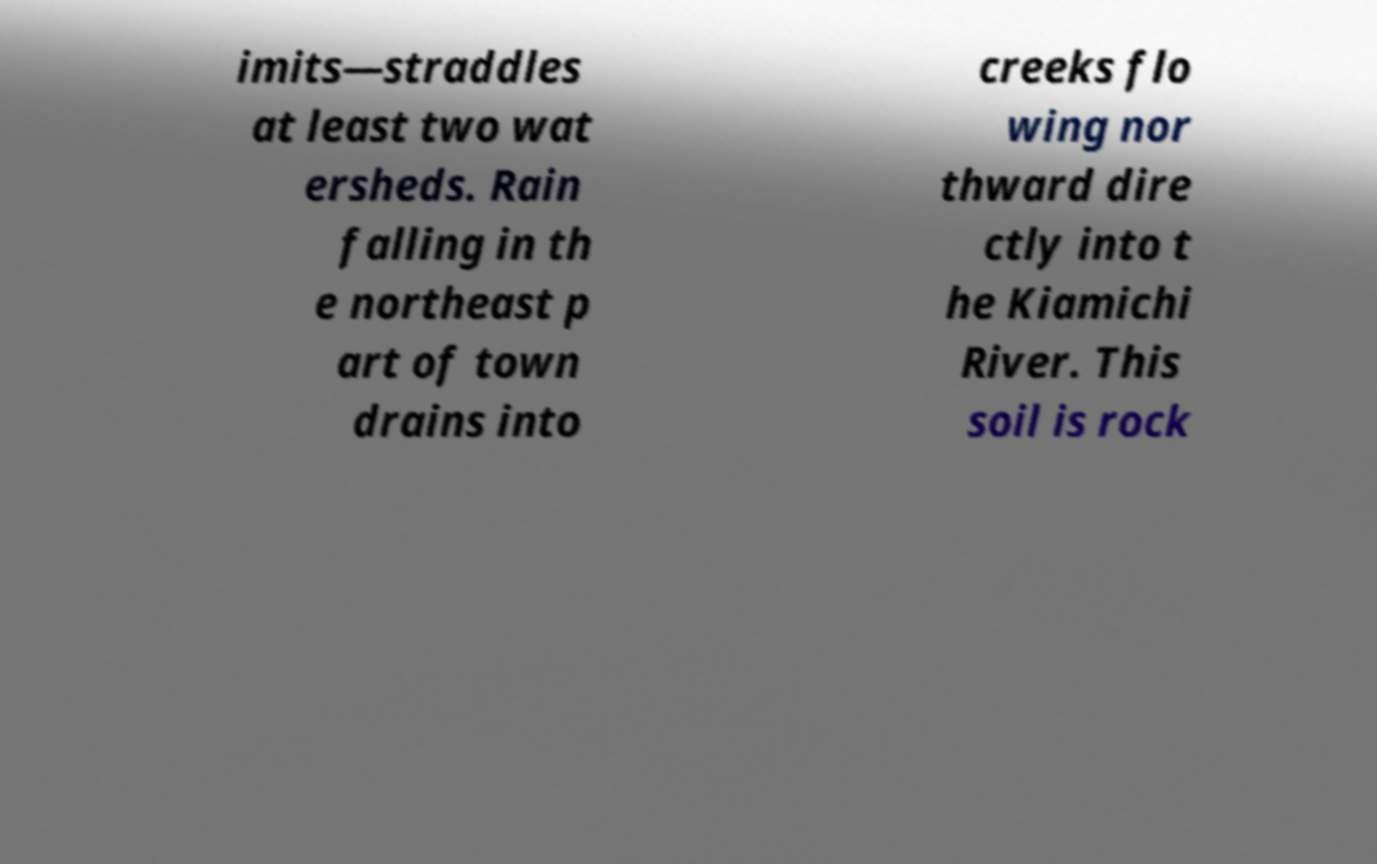Can you accurately transcribe the text from the provided image for me? imits—straddles at least two wat ersheds. Rain falling in th e northeast p art of town drains into creeks flo wing nor thward dire ctly into t he Kiamichi River. This soil is rock 